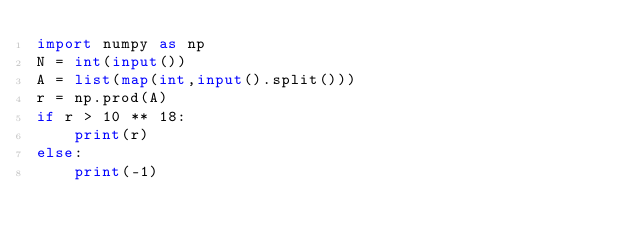Convert code to text. <code><loc_0><loc_0><loc_500><loc_500><_Python_>import numpy as np
N = int(input())
A = list(map(int,input().split()))
r = np.prod(A)
if r > 10 ** 18:
    print(r)
else:
    print(-1)</code> 